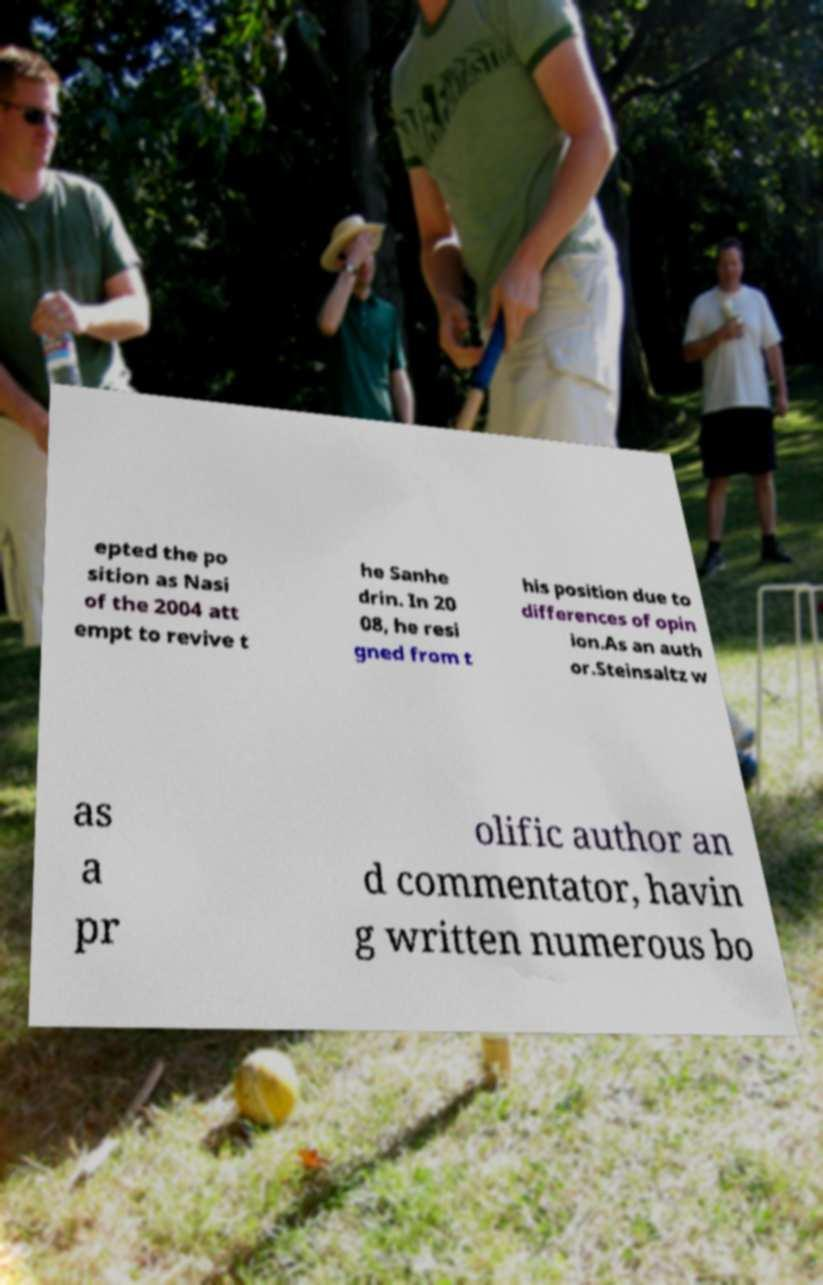There's text embedded in this image that I need extracted. Can you transcribe it verbatim? epted the po sition as Nasi of the 2004 att empt to revive t he Sanhe drin. In 20 08, he resi gned from t his position due to differences of opin ion.As an auth or.Steinsaltz w as a pr olific author an d commentator, havin g written numerous bo 